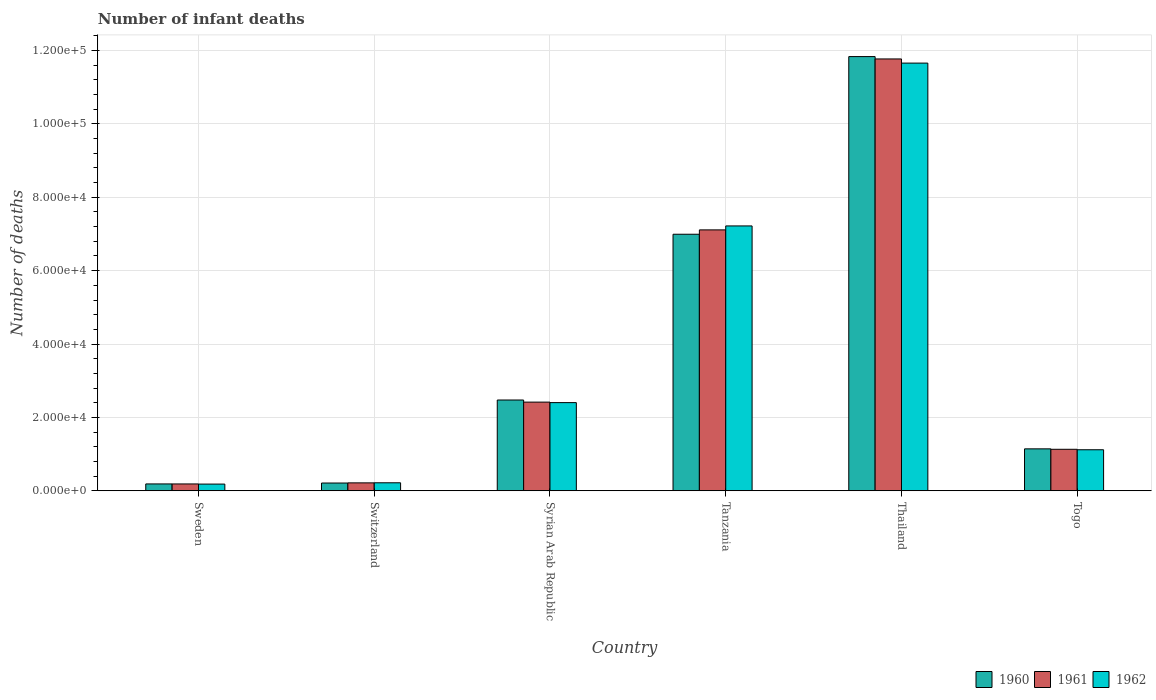How many bars are there on the 5th tick from the left?
Give a very brief answer. 3. What is the label of the 6th group of bars from the left?
Keep it short and to the point. Togo. What is the number of infant deaths in 1960 in Togo?
Your response must be concise. 1.14e+04. Across all countries, what is the maximum number of infant deaths in 1960?
Ensure brevity in your answer.  1.18e+05. Across all countries, what is the minimum number of infant deaths in 1962?
Your answer should be very brief. 1827. In which country was the number of infant deaths in 1960 maximum?
Offer a terse response. Thailand. What is the total number of infant deaths in 1962 in the graph?
Ensure brevity in your answer.  2.28e+05. What is the difference between the number of infant deaths in 1960 in Sweden and that in Tanzania?
Provide a succinct answer. -6.81e+04. What is the difference between the number of infant deaths in 1961 in Switzerland and the number of infant deaths in 1960 in Togo?
Ensure brevity in your answer.  -9274. What is the average number of infant deaths in 1960 per country?
Provide a short and direct response. 3.81e+04. What is the difference between the number of infant deaths of/in 1960 and number of infant deaths of/in 1962 in Thailand?
Ensure brevity in your answer.  1775. What is the ratio of the number of infant deaths in 1961 in Syrian Arab Republic to that in Togo?
Ensure brevity in your answer.  2.14. Is the number of infant deaths in 1961 in Syrian Arab Republic less than that in Thailand?
Offer a terse response. Yes. What is the difference between the highest and the second highest number of infant deaths in 1960?
Your answer should be very brief. 9.36e+04. What is the difference between the highest and the lowest number of infant deaths in 1961?
Your response must be concise. 1.16e+05. What does the 3rd bar from the left in Switzerland represents?
Your response must be concise. 1962. What is the difference between two consecutive major ticks on the Y-axis?
Your answer should be very brief. 2.00e+04. Does the graph contain any zero values?
Your answer should be very brief. No. Where does the legend appear in the graph?
Your response must be concise. Bottom right. How many legend labels are there?
Provide a short and direct response. 3. What is the title of the graph?
Provide a succinct answer. Number of infant deaths. Does "1983" appear as one of the legend labels in the graph?
Your answer should be very brief. No. What is the label or title of the X-axis?
Your answer should be very brief. Country. What is the label or title of the Y-axis?
Offer a terse response. Number of deaths. What is the Number of deaths of 1960 in Sweden?
Keep it short and to the point. 1868. What is the Number of deaths in 1961 in Sweden?
Provide a succinct answer. 1865. What is the Number of deaths of 1962 in Sweden?
Give a very brief answer. 1827. What is the Number of deaths of 1960 in Switzerland?
Provide a short and direct response. 2116. What is the Number of deaths in 1961 in Switzerland?
Keep it short and to the point. 2157. What is the Number of deaths in 1962 in Switzerland?
Provide a short and direct response. 2179. What is the Number of deaths of 1960 in Syrian Arab Republic?
Your response must be concise. 2.47e+04. What is the Number of deaths in 1961 in Syrian Arab Republic?
Make the answer very short. 2.42e+04. What is the Number of deaths in 1962 in Syrian Arab Republic?
Offer a very short reply. 2.40e+04. What is the Number of deaths of 1960 in Tanzania?
Give a very brief answer. 6.99e+04. What is the Number of deaths in 1961 in Tanzania?
Ensure brevity in your answer.  7.11e+04. What is the Number of deaths in 1962 in Tanzania?
Provide a short and direct response. 7.22e+04. What is the Number of deaths in 1960 in Thailand?
Your answer should be very brief. 1.18e+05. What is the Number of deaths in 1961 in Thailand?
Your answer should be compact. 1.18e+05. What is the Number of deaths of 1962 in Thailand?
Keep it short and to the point. 1.17e+05. What is the Number of deaths in 1960 in Togo?
Your answer should be compact. 1.14e+04. What is the Number of deaths of 1961 in Togo?
Offer a terse response. 1.13e+04. What is the Number of deaths in 1962 in Togo?
Make the answer very short. 1.12e+04. Across all countries, what is the maximum Number of deaths of 1960?
Provide a short and direct response. 1.18e+05. Across all countries, what is the maximum Number of deaths of 1961?
Provide a short and direct response. 1.18e+05. Across all countries, what is the maximum Number of deaths of 1962?
Keep it short and to the point. 1.17e+05. Across all countries, what is the minimum Number of deaths of 1960?
Offer a terse response. 1868. Across all countries, what is the minimum Number of deaths in 1961?
Provide a succinct answer. 1865. Across all countries, what is the minimum Number of deaths in 1962?
Keep it short and to the point. 1827. What is the total Number of deaths in 1960 in the graph?
Offer a very short reply. 2.28e+05. What is the total Number of deaths in 1961 in the graph?
Keep it short and to the point. 2.28e+05. What is the total Number of deaths of 1962 in the graph?
Offer a terse response. 2.28e+05. What is the difference between the Number of deaths of 1960 in Sweden and that in Switzerland?
Ensure brevity in your answer.  -248. What is the difference between the Number of deaths in 1961 in Sweden and that in Switzerland?
Your answer should be compact. -292. What is the difference between the Number of deaths of 1962 in Sweden and that in Switzerland?
Ensure brevity in your answer.  -352. What is the difference between the Number of deaths of 1960 in Sweden and that in Syrian Arab Republic?
Keep it short and to the point. -2.29e+04. What is the difference between the Number of deaths in 1961 in Sweden and that in Syrian Arab Republic?
Ensure brevity in your answer.  -2.23e+04. What is the difference between the Number of deaths in 1962 in Sweden and that in Syrian Arab Republic?
Your answer should be compact. -2.22e+04. What is the difference between the Number of deaths in 1960 in Sweden and that in Tanzania?
Your response must be concise. -6.81e+04. What is the difference between the Number of deaths of 1961 in Sweden and that in Tanzania?
Your answer should be very brief. -6.92e+04. What is the difference between the Number of deaths in 1962 in Sweden and that in Tanzania?
Your answer should be compact. -7.04e+04. What is the difference between the Number of deaths of 1960 in Sweden and that in Thailand?
Provide a succinct answer. -1.16e+05. What is the difference between the Number of deaths of 1961 in Sweden and that in Thailand?
Provide a short and direct response. -1.16e+05. What is the difference between the Number of deaths of 1962 in Sweden and that in Thailand?
Your response must be concise. -1.15e+05. What is the difference between the Number of deaths of 1960 in Sweden and that in Togo?
Make the answer very short. -9563. What is the difference between the Number of deaths of 1961 in Sweden and that in Togo?
Provide a succinct answer. -9446. What is the difference between the Number of deaths in 1962 in Sweden and that in Togo?
Provide a short and direct response. -9358. What is the difference between the Number of deaths of 1960 in Switzerland and that in Syrian Arab Republic?
Give a very brief answer. -2.26e+04. What is the difference between the Number of deaths in 1961 in Switzerland and that in Syrian Arab Republic?
Provide a succinct answer. -2.20e+04. What is the difference between the Number of deaths of 1962 in Switzerland and that in Syrian Arab Republic?
Provide a short and direct response. -2.19e+04. What is the difference between the Number of deaths in 1960 in Switzerland and that in Tanzania?
Provide a succinct answer. -6.78e+04. What is the difference between the Number of deaths of 1961 in Switzerland and that in Tanzania?
Ensure brevity in your answer.  -6.90e+04. What is the difference between the Number of deaths of 1962 in Switzerland and that in Tanzania?
Your answer should be compact. -7.00e+04. What is the difference between the Number of deaths in 1960 in Switzerland and that in Thailand?
Your answer should be compact. -1.16e+05. What is the difference between the Number of deaths of 1961 in Switzerland and that in Thailand?
Your answer should be compact. -1.16e+05. What is the difference between the Number of deaths in 1962 in Switzerland and that in Thailand?
Your answer should be compact. -1.14e+05. What is the difference between the Number of deaths in 1960 in Switzerland and that in Togo?
Offer a very short reply. -9315. What is the difference between the Number of deaths of 1961 in Switzerland and that in Togo?
Ensure brevity in your answer.  -9154. What is the difference between the Number of deaths in 1962 in Switzerland and that in Togo?
Give a very brief answer. -9006. What is the difference between the Number of deaths of 1960 in Syrian Arab Republic and that in Tanzania?
Your answer should be very brief. -4.52e+04. What is the difference between the Number of deaths of 1961 in Syrian Arab Republic and that in Tanzania?
Provide a succinct answer. -4.69e+04. What is the difference between the Number of deaths of 1962 in Syrian Arab Republic and that in Tanzania?
Offer a terse response. -4.82e+04. What is the difference between the Number of deaths in 1960 in Syrian Arab Republic and that in Thailand?
Offer a very short reply. -9.36e+04. What is the difference between the Number of deaths of 1961 in Syrian Arab Republic and that in Thailand?
Provide a succinct answer. -9.35e+04. What is the difference between the Number of deaths of 1962 in Syrian Arab Republic and that in Thailand?
Give a very brief answer. -9.25e+04. What is the difference between the Number of deaths in 1960 in Syrian Arab Republic and that in Togo?
Offer a terse response. 1.33e+04. What is the difference between the Number of deaths in 1961 in Syrian Arab Republic and that in Togo?
Provide a short and direct response. 1.29e+04. What is the difference between the Number of deaths in 1962 in Syrian Arab Republic and that in Togo?
Ensure brevity in your answer.  1.28e+04. What is the difference between the Number of deaths in 1960 in Tanzania and that in Thailand?
Offer a terse response. -4.84e+04. What is the difference between the Number of deaths of 1961 in Tanzania and that in Thailand?
Make the answer very short. -4.66e+04. What is the difference between the Number of deaths of 1962 in Tanzania and that in Thailand?
Your answer should be very brief. -4.44e+04. What is the difference between the Number of deaths of 1960 in Tanzania and that in Togo?
Give a very brief answer. 5.85e+04. What is the difference between the Number of deaths of 1961 in Tanzania and that in Togo?
Give a very brief answer. 5.98e+04. What is the difference between the Number of deaths of 1962 in Tanzania and that in Togo?
Provide a short and direct response. 6.10e+04. What is the difference between the Number of deaths in 1960 in Thailand and that in Togo?
Give a very brief answer. 1.07e+05. What is the difference between the Number of deaths in 1961 in Thailand and that in Togo?
Your answer should be compact. 1.06e+05. What is the difference between the Number of deaths in 1962 in Thailand and that in Togo?
Your response must be concise. 1.05e+05. What is the difference between the Number of deaths in 1960 in Sweden and the Number of deaths in 1961 in Switzerland?
Provide a succinct answer. -289. What is the difference between the Number of deaths in 1960 in Sweden and the Number of deaths in 1962 in Switzerland?
Your response must be concise. -311. What is the difference between the Number of deaths of 1961 in Sweden and the Number of deaths of 1962 in Switzerland?
Keep it short and to the point. -314. What is the difference between the Number of deaths in 1960 in Sweden and the Number of deaths in 1961 in Syrian Arab Republic?
Your answer should be very brief. -2.23e+04. What is the difference between the Number of deaths of 1960 in Sweden and the Number of deaths of 1962 in Syrian Arab Republic?
Your answer should be very brief. -2.22e+04. What is the difference between the Number of deaths of 1961 in Sweden and the Number of deaths of 1962 in Syrian Arab Republic?
Your answer should be very brief. -2.22e+04. What is the difference between the Number of deaths of 1960 in Sweden and the Number of deaths of 1961 in Tanzania?
Make the answer very short. -6.92e+04. What is the difference between the Number of deaths in 1960 in Sweden and the Number of deaths in 1962 in Tanzania?
Keep it short and to the point. -7.03e+04. What is the difference between the Number of deaths in 1961 in Sweden and the Number of deaths in 1962 in Tanzania?
Offer a terse response. -7.03e+04. What is the difference between the Number of deaths of 1960 in Sweden and the Number of deaths of 1961 in Thailand?
Keep it short and to the point. -1.16e+05. What is the difference between the Number of deaths in 1960 in Sweden and the Number of deaths in 1962 in Thailand?
Keep it short and to the point. -1.15e+05. What is the difference between the Number of deaths of 1961 in Sweden and the Number of deaths of 1962 in Thailand?
Offer a terse response. -1.15e+05. What is the difference between the Number of deaths in 1960 in Sweden and the Number of deaths in 1961 in Togo?
Provide a succinct answer. -9443. What is the difference between the Number of deaths of 1960 in Sweden and the Number of deaths of 1962 in Togo?
Give a very brief answer. -9317. What is the difference between the Number of deaths in 1961 in Sweden and the Number of deaths in 1962 in Togo?
Provide a succinct answer. -9320. What is the difference between the Number of deaths of 1960 in Switzerland and the Number of deaths of 1961 in Syrian Arab Republic?
Provide a short and direct response. -2.21e+04. What is the difference between the Number of deaths in 1960 in Switzerland and the Number of deaths in 1962 in Syrian Arab Republic?
Keep it short and to the point. -2.19e+04. What is the difference between the Number of deaths of 1961 in Switzerland and the Number of deaths of 1962 in Syrian Arab Republic?
Offer a terse response. -2.19e+04. What is the difference between the Number of deaths in 1960 in Switzerland and the Number of deaths in 1961 in Tanzania?
Ensure brevity in your answer.  -6.90e+04. What is the difference between the Number of deaths in 1960 in Switzerland and the Number of deaths in 1962 in Tanzania?
Keep it short and to the point. -7.01e+04. What is the difference between the Number of deaths of 1961 in Switzerland and the Number of deaths of 1962 in Tanzania?
Keep it short and to the point. -7.00e+04. What is the difference between the Number of deaths of 1960 in Switzerland and the Number of deaths of 1961 in Thailand?
Make the answer very short. -1.16e+05. What is the difference between the Number of deaths in 1960 in Switzerland and the Number of deaths in 1962 in Thailand?
Ensure brevity in your answer.  -1.14e+05. What is the difference between the Number of deaths of 1961 in Switzerland and the Number of deaths of 1962 in Thailand?
Ensure brevity in your answer.  -1.14e+05. What is the difference between the Number of deaths of 1960 in Switzerland and the Number of deaths of 1961 in Togo?
Offer a terse response. -9195. What is the difference between the Number of deaths in 1960 in Switzerland and the Number of deaths in 1962 in Togo?
Offer a terse response. -9069. What is the difference between the Number of deaths of 1961 in Switzerland and the Number of deaths of 1962 in Togo?
Your answer should be compact. -9028. What is the difference between the Number of deaths of 1960 in Syrian Arab Republic and the Number of deaths of 1961 in Tanzania?
Give a very brief answer. -4.64e+04. What is the difference between the Number of deaths of 1960 in Syrian Arab Republic and the Number of deaths of 1962 in Tanzania?
Ensure brevity in your answer.  -4.74e+04. What is the difference between the Number of deaths of 1961 in Syrian Arab Republic and the Number of deaths of 1962 in Tanzania?
Make the answer very short. -4.80e+04. What is the difference between the Number of deaths of 1960 in Syrian Arab Republic and the Number of deaths of 1961 in Thailand?
Offer a very short reply. -9.30e+04. What is the difference between the Number of deaths of 1960 in Syrian Arab Republic and the Number of deaths of 1962 in Thailand?
Provide a succinct answer. -9.18e+04. What is the difference between the Number of deaths in 1961 in Syrian Arab Republic and the Number of deaths in 1962 in Thailand?
Your answer should be compact. -9.24e+04. What is the difference between the Number of deaths of 1960 in Syrian Arab Republic and the Number of deaths of 1961 in Togo?
Provide a short and direct response. 1.34e+04. What is the difference between the Number of deaths of 1960 in Syrian Arab Republic and the Number of deaths of 1962 in Togo?
Offer a terse response. 1.36e+04. What is the difference between the Number of deaths of 1961 in Syrian Arab Republic and the Number of deaths of 1962 in Togo?
Your answer should be very brief. 1.30e+04. What is the difference between the Number of deaths in 1960 in Tanzania and the Number of deaths in 1961 in Thailand?
Provide a short and direct response. -4.78e+04. What is the difference between the Number of deaths in 1960 in Tanzania and the Number of deaths in 1962 in Thailand?
Ensure brevity in your answer.  -4.66e+04. What is the difference between the Number of deaths in 1961 in Tanzania and the Number of deaths in 1962 in Thailand?
Offer a terse response. -4.55e+04. What is the difference between the Number of deaths of 1960 in Tanzania and the Number of deaths of 1961 in Togo?
Offer a terse response. 5.86e+04. What is the difference between the Number of deaths in 1960 in Tanzania and the Number of deaths in 1962 in Togo?
Provide a short and direct response. 5.87e+04. What is the difference between the Number of deaths in 1961 in Tanzania and the Number of deaths in 1962 in Togo?
Make the answer very short. 5.99e+04. What is the difference between the Number of deaths in 1960 in Thailand and the Number of deaths in 1961 in Togo?
Your answer should be compact. 1.07e+05. What is the difference between the Number of deaths in 1960 in Thailand and the Number of deaths in 1962 in Togo?
Ensure brevity in your answer.  1.07e+05. What is the difference between the Number of deaths in 1961 in Thailand and the Number of deaths in 1962 in Togo?
Offer a terse response. 1.07e+05. What is the average Number of deaths of 1960 per country?
Make the answer very short. 3.81e+04. What is the average Number of deaths in 1961 per country?
Offer a very short reply. 3.81e+04. What is the average Number of deaths of 1962 per country?
Offer a very short reply. 3.80e+04. What is the difference between the Number of deaths of 1960 and Number of deaths of 1961 in Sweden?
Provide a succinct answer. 3. What is the difference between the Number of deaths of 1960 and Number of deaths of 1962 in Sweden?
Provide a succinct answer. 41. What is the difference between the Number of deaths of 1960 and Number of deaths of 1961 in Switzerland?
Provide a succinct answer. -41. What is the difference between the Number of deaths of 1960 and Number of deaths of 1962 in Switzerland?
Your response must be concise. -63. What is the difference between the Number of deaths in 1960 and Number of deaths in 1961 in Syrian Arab Republic?
Provide a short and direct response. 572. What is the difference between the Number of deaths of 1960 and Number of deaths of 1962 in Syrian Arab Republic?
Your response must be concise. 711. What is the difference between the Number of deaths in 1961 and Number of deaths in 1962 in Syrian Arab Republic?
Provide a succinct answer. 139. What is the difference between the Number of deaths in 1960 and Number of deaths in 1961 in Tanzania?
Keep it short and to the point. -1186. What is the difference between the Number of deaths of 1960 and Number of deaths of 1962 in Tanzania?
Ensure brevity in your answer.  -2266. What is the difference between the Number of deaths of 1961 and Number of deaths of 1962 in Tanzania?
Give a very brief answer. -1080. What is the difference between the Number of deaths of 1960 and Number of deaths of 1961 in Thailand?
Your response must be concise. 643. What is the difference between the Number of deaths of 1960 and Number of deaths of 1962 in Thailand?
Provide a short and direct response. 1775. What is the difference between the Number of deaths of 1961 and Number of deaths of 1962 in Thailand?
Provide a succinct answer. 1132. What is the difference between the Number of deaths of 1960 and Number of deaths of 1961 in Togo?
Keep it short and to the point. 120. What is the difference between the Number of deaths in 1960 and Number of deaths in 1962 in Togo?
Your response must be concise. 246. What is the difference between the Number of deaths in 1961 and Number of deaths in 1962 in Togo?
Offer a very short reply. 126. What is the ratio of the Number of deaths of 1960 in Sweden to that in Switzerland?
Give a very brief answer. 0.88. What is the ratio of the Number of deaths in 1961 in Sweden to that in Switzerland?
Ensure brevity in your answer.  0.86. What is the ratio of the Number of deaths in 1962 in Sweden to that in Switzerland?
Your response must be concise. 0.84. What is the ratio of the Number of deaths in 1960 in Sweden to that in Syrian Arab Republic?
Provide a short and direct response. 0.08. What is the ratio of the Number of deaths of 1961 in Sweden to that in Syrian Arab Republic?
Provide a short and direct response. 0.08. What is the ratio of the Number of deaths of 1962 in Sweden to that in Syrian Arab Republic?
Offer a terse response. 0.08. What is the ratio of the Number of deaths of 1960 in Sweden to that in Tanzania?
Your answer should be very brief. 0.03. What is the ratio of the Number of deaths of 1961 in Sweden to that in Tanzania?
Offer a very short reply. 0.03. What is the ratio of the Number of deaths of 1962 in Sweden to that in Tanzania?
Provide a succinct answer. 0.03. What is the ratio of the Number of deaths of 1960 in Sweden to that in Thailand?
Provide a short and direct response. 0.02. What is the ratio of the Number of deaths of 1961 in Sweden to that in Thailand?
Keep it short and to the point. 0.02. What is the ratio of the Number of deaths of 1962 in Sweden to that in Thailand?
Make the answer very short. 0.02. What is the ratio of the Number of deaths of 1960 in Sweden to that in Togo?
Offer a terse response. 0.16. What is the ratio of the Number of deaths of 1961 in Sweden to that in Togo?
Provide a short and direct response. 0.16. What is the ratio of the Number of deaths in 1962 in Sweden to that in Togo?
Your answer should be very brief. 0.16. What is the ratio of the Number of deaths of 1960 in Switzerland to that in Syrian Arab Republic?
Offer a terse response. 0.09. What is the ratio of the Number of deaths in 1961 in Switzerland to that in Syrian Arab Republic?
Give a very brief answer. 0.09. What is the ratio of the Number of deaths of 1962 in Switzerland to that in Syrian Arab Republic?
Ensure brevity in your answer.  0.09. What is the ratio of the Number of deaths in 1960 in Switzerland to that in Tanzania?
Ensure brevity in your answer.  0.03. What is the ratio of the Number of deaths in 1961 in Switzerland to that in Tanzania?
Provide a succinct answer. 0.03. What is the ratio of the Number of deaths of 1962 in Switzerland to that in Tanzania?
Give a very brief answer. 0.03. What is the ratio of the Number of deaths in 1960 in Switzerland to that in Thailand?
Provide a short and direct response. 0.02. What is the ratio of the Number of deaths in 1961 in Switzerland to that in Thailand?
Offer a terse response. 0.02. What is the ratio of the Number of deaths of 1962 in Switzerland to that in Thailand?
Offer a terse response. 0.02. What is the ratio of the Number of deaths of 1960 in Switzerland to that in Togo?
Offer a terse response. 0.19. What is the ratio of the Number of deaths of 1961 in Switzerland to that in Togo?
Keep it short and to the point. 0.19. What is the ratio of the Number of deaths of 1962 in Switzerland to that in Togo?
Keep it short and to the point. 0.19. What is the ratio of the Number of deaths in 1960 in Syrian Arab Republic to that in Tanzania?
Your response must be concise. 0.35. What is the ratio of the Number of deaths of 1961 in Syrian Arab Republic to that in Tanzania?
Your answer should be very brief. 0.34. What is the ratio of the Number of deaths in 1962 in Syrian Arab Republic to that in Tanzania?
Offer a very short reply. 0.33. What is the ratio of the Number of deaths in 1960 in Syrian Arab Republic to that in Thailand?
Ensure brevity in your answer.  0.21. What is the ratio of the Number of deaths of 1961 in Syrian Arab Republic to that in Thailand?
Your answer should be very brief. 0.21. What is the ratio of the Number of deaths of 1962 in Syrian Arab Republic to that in Thailand?
Offer a very short reply. 0.21. What is the ratio of the Number of deaths of 1960 in Syrian Arab Republic to that in Togo?
Offer a terse response. 2.16. What is the ratio of the Number of deaths in 1961 in Syrian Arab Republic to that in Togo?
Offer a terse response. 2.14. What is the ratio of the Number of deaths of 1962 in Syrian Arab Republic to that in Togo?
Make the answer very short. 2.15. What is the ratio of the Number of deaths of 1960 in Tanzania to that in Thailand?
Your response must be concise. 0.59. What is the ratio of the Number of deaths in 1961 in Tanzania to that in Thailand?
Ensure brevity in your answer.  0.6. What is the ratio of the Number of deaths in 1962 in Tanzania to that in Thailand?
Your answer should be compact. 0.62. What is the ratio of the Number of deaths of 1960 in Tanzania to that in Togo?
Ensure brevity in your answer.  6.12. What is the ratio of the Number of deaths in 1961 in Tanzania to that in Togo?
Give a very brief answer. 6.29. What is the ratio of the Number of deaths in 1962 in Tanzania to that in Togo?
Give a very brief answer. 6.45. What is the ratio of the Number of deaths in 1960 in Thailand to that in Togo?
Keep it short and to the point. 10.35. What is the ratio of the Number of deaths of 1961 in Thailand to that in Togo?
Make the answer very short. 10.41. What is the ratio of the Number of deaths of 1962 in Thailand to that in Togo?
Give a very brief answer. 10.42. What is the difference between the highest and the second highest Number of deaths of 1960?
Provide a succinct answer. 4.84e+04. What is the difference between the highest and the second highest Number of deaths in 1961?
Ensure brevity in your answer.  4.66e+04. What is the difference between the highest and the second highest Number of deaths in 1962?
Give a very brief answer. 4.44e+04. What is the difference between the highest and the lowest Number of deaths in 1960?
Your response must be concise. 1.16e+05. What is the difference between the highest and the lowest Number of deaths of 1961?
Offer a terse response. 1.16e+05. What is the difference between the highest and the lowest Number of deaths of 1962?
Make the answer very short. 1.15e+05. 